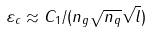<formula> <loc_0><loc_0><loc_500><loc_500>\varepsilon _ { c } \approx C _ { 1 } / ( n _ { g } \sqrt { n _ { q } } \sqrt { l } )</formula> 